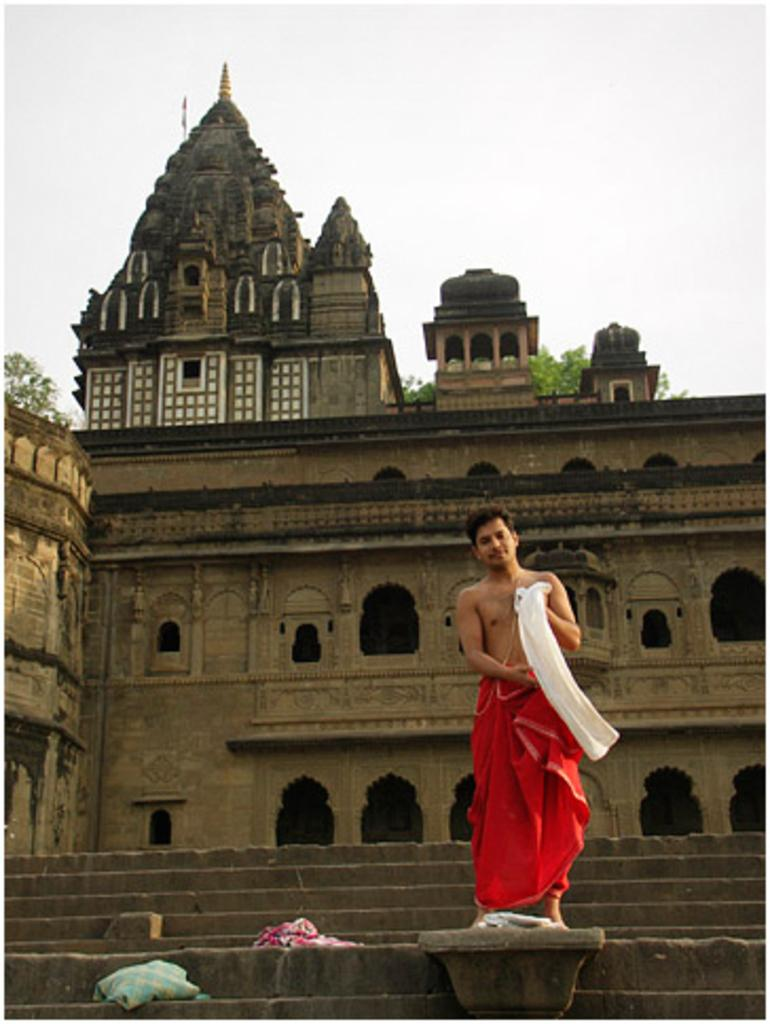What is the main subject of the image? There is a person in the image. What is the person wearing? The person is wearing a red color lungi. Where is the person standing in the image? The person is standing on the stairs. What can be seen in the background of the image? There is an ancient temple and trees in the background of the image. What type of memory is the person trying to recall in the image? There is no indication in the image that the person is trying to recall any memory. What action is the person performing with the eggs in the image? There are no eggs present in the image. 